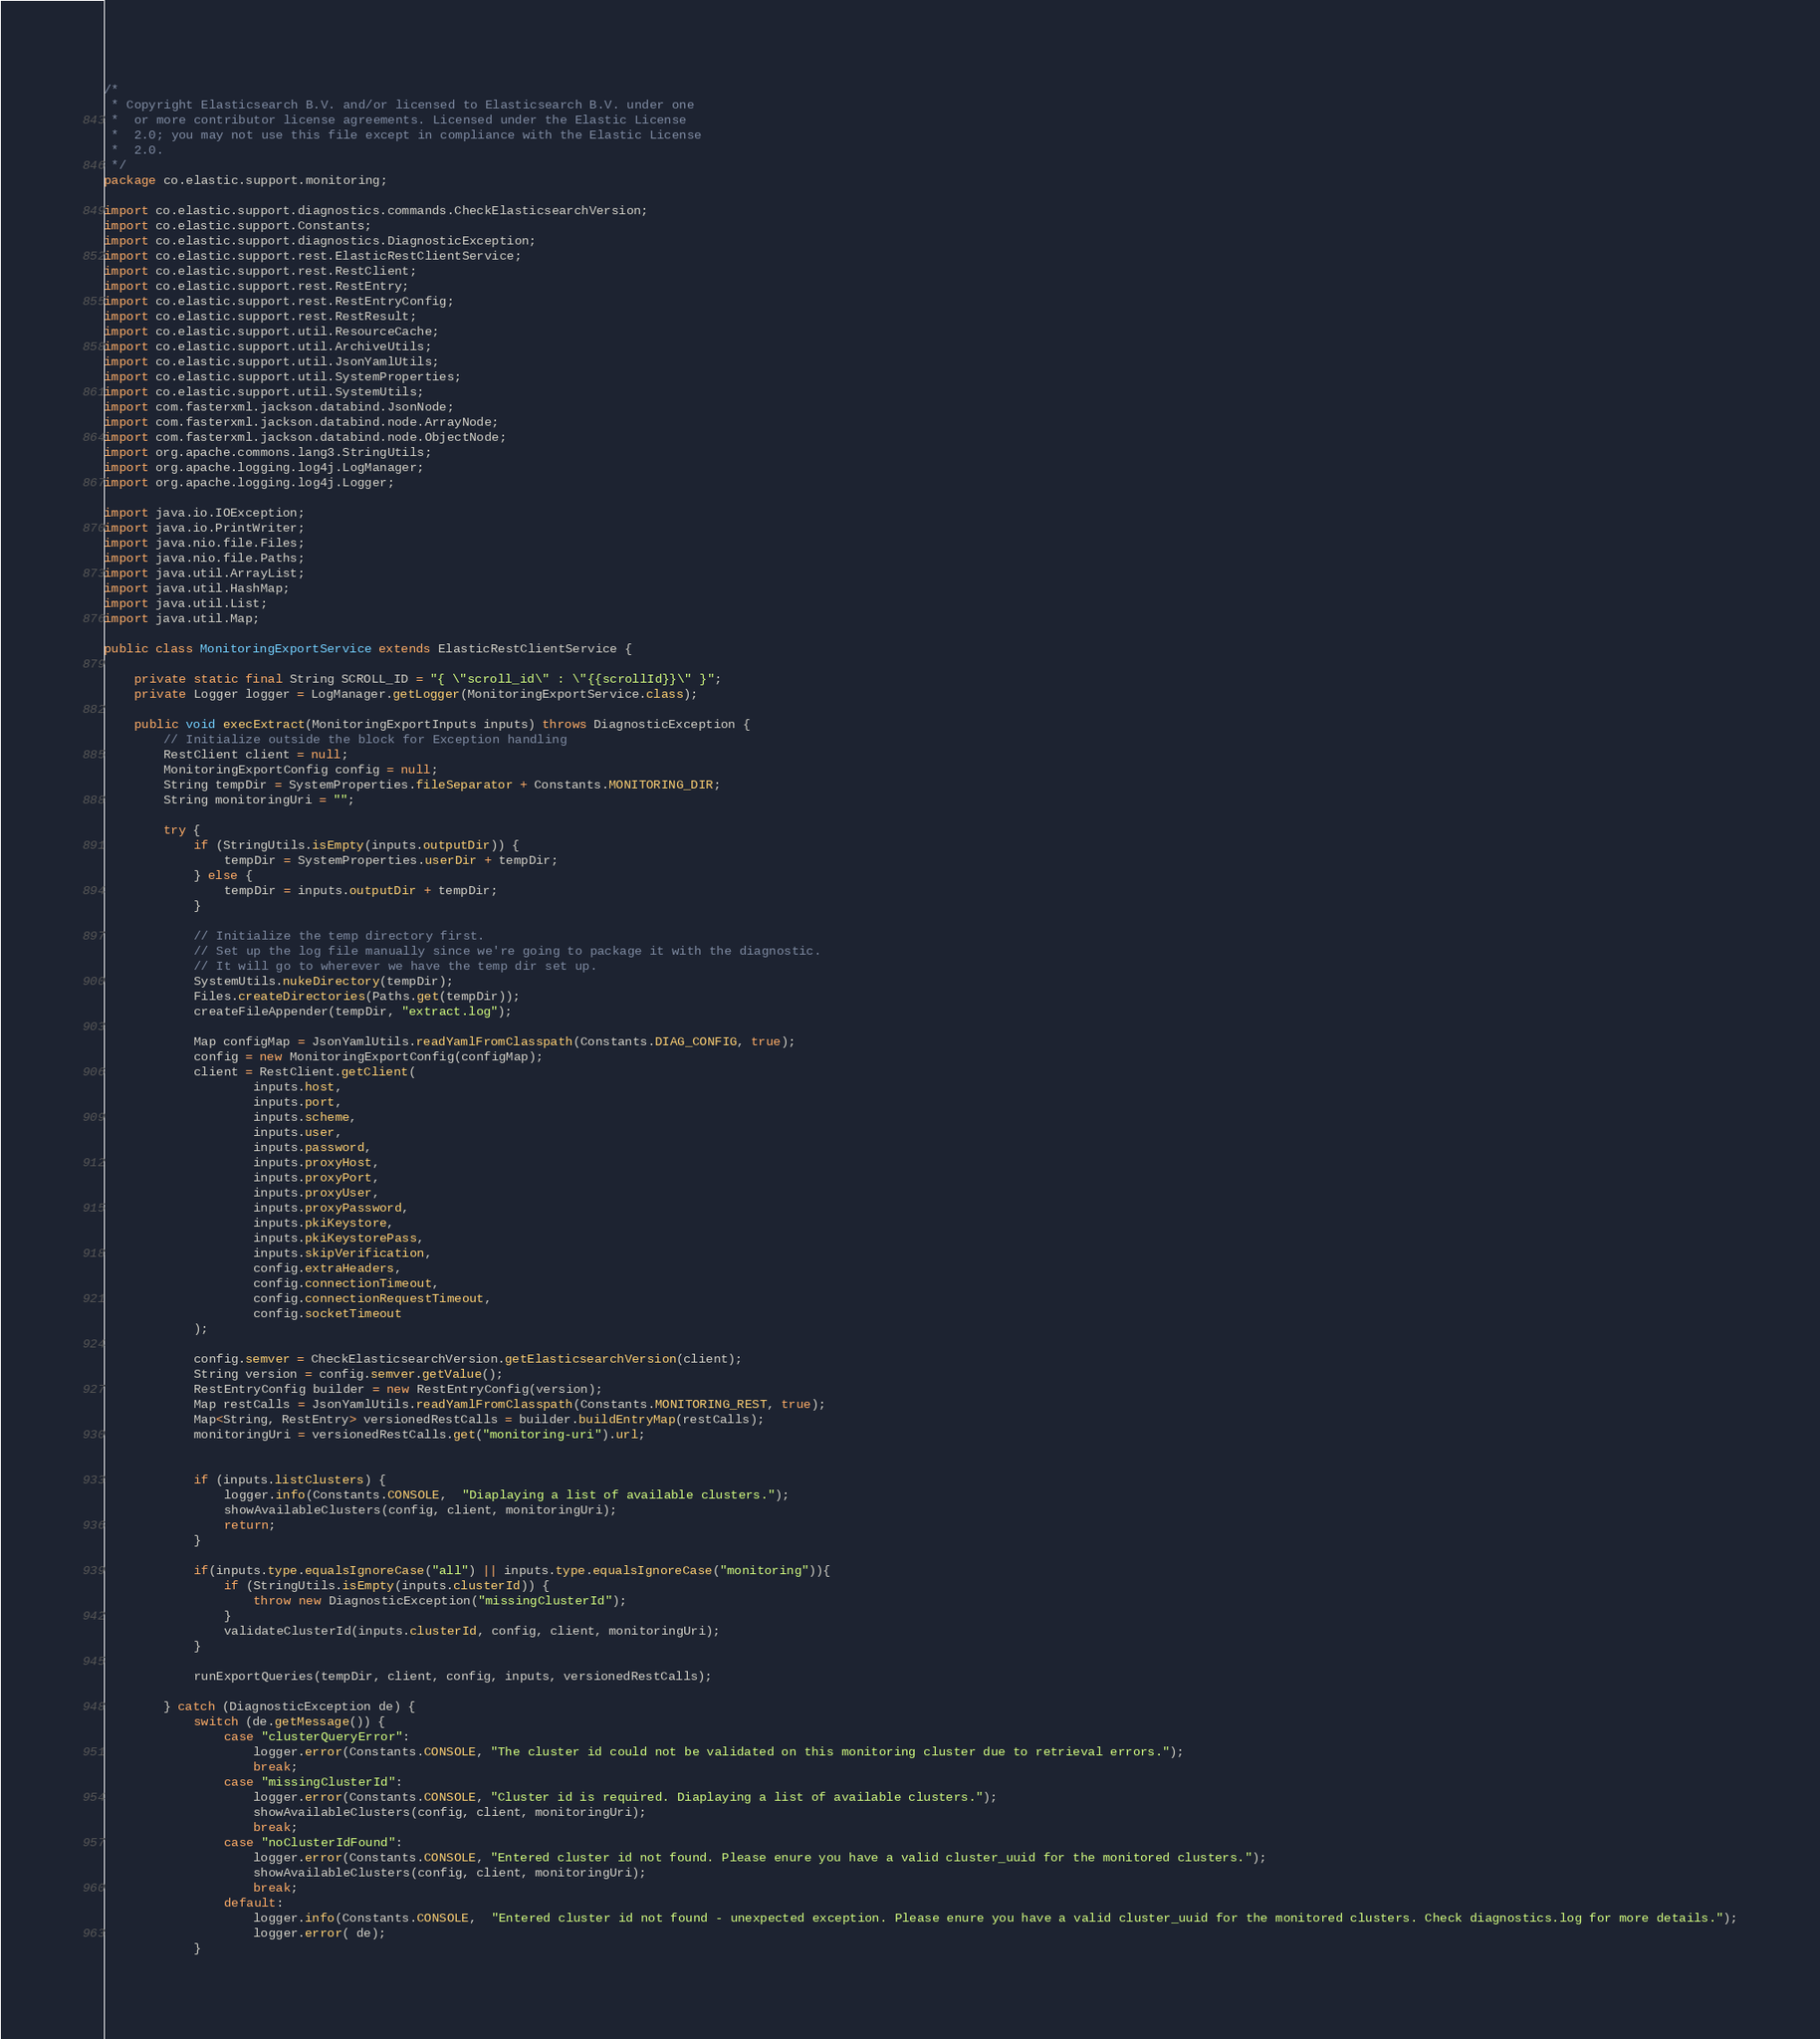Convert code to text. <code><loc_0><loc_0><loc_500><loc_500><_Java_>/*
 * Copyright Elasticsearch B.V. and/or licensed to Elasticsearch B.V. under one
 *  or more contributor license agreements. Licensed under the Elastic License
 *  2.0; you may not use this file except in compliance with the Elastic License
 *  2.0.
 */
package co.elastic.support.monitoring;

import co.elastic.support.diagnostics.commands.CheckElasticsearchVersion;
import co.elastic.support.Constants;
import co.elastic.support.diagnostics.DiagnosticException;
import co.elastic.support.rest.ElasticRestClientService;
import co.elastic.support.rest.RestClient;
import co.elastic.support.rest.RestEntry;
import co.elastic.support.rest.RestEntryConfig;
import co.elastic.support.rest.RestResult;
import co.elastic.support.util.ResourceCache;
import co.elastic.support.util.ArchiveUtils;
import co.elastic.support.util.JsonYamlUtils;
import co.elastic.support.util.SystemProperties;
import co.elastic.support.util.SystemUtils;
import com.fasterxml.jackson.databind.JsonNode;
import com.fasterxml.jackson.databind.node.ArrayNode;
import com.fasterxml.jackson.databind.node.ObjectNode;
import org.apache.commons.lang3.StringUtils;
import org.apache.logging.log4j.LogManager;
import org.apache.logging.log4j.Logger;

import java.io.IOException;
import java.io.PrintWriter;
import java.nio.file.Files;
import java.nio.file.Paths;
import java.util.ArrayList;
import java.util.HashMap;
import java.util.List;
import java.util.Map;

public class MonitoringExportService extends ElasticRestClientService {

    private static final String SCROLL_ID = "{ \"scroll_id\" : \"{{scrollId}}\" }";
    private Logger logger = LogManager.getLogger(MonitoringExportService.class);

    public void execExtract(MonitoringExportInputs inputs) throws DiagnosticException {
        // Initialize outside the block for Exception handling
        RestClient client = null;
        MonitoringExportConfig config = null;
        String tempDir = SystemProperties.fileSeparator + Constants.MONITORING_DIR;
        String monitoringUri = "";

        try {
            if (StringUtils.isEmpty(inputs.outputDir)) {
                tempDir = SystemProperties.userDir + tempDir;
            } else {
                tempDir = inputs.outputDir + tempDir;
            }

            // Initialize the temp directory first.
            // Set up the log file manually since we're going to package it with the diagnostic.
            // It will go to wherever we have the temp dir set up.
            SystemUtils.nukeDirectory(tempDir);
            Files.createDirectories(Paths.get(tempDir));
            createFileAppender(tempDir, "extract.log");

            Map configMap = JsonYamlUtils.readYamlFromClasspath(Constants.DIAG_CONFIG, true);
            config = new MonitoringExportConfig(configMap);
            client = RestClient.getClient(
                    inputs.host,
                    inputs.port,
                    inputs.scheme,
                    inputs.user,
                    inputs.password,
                    inputs.proxyHost,
                    inputs.proxyPort,
                    inputs.proxyUser,
                    inputs.proxyPassword,
                    inputs.pkiKeystore,
                    inputs.pkiKeystorePass,
                    inputs.skipVerification,
                    config.extraHeaders,
                    config.connectionTimeout,
                    config.connectionRequestTimeout,
                    config.socketTimeout
            );

            config.semver = CheckElasticsearchVersion.getElasticsearchVersion(client);
            String version = config.semver.getValue();
            RestEntryConfig builder = new RestEntryConfig(version);
            Map restCalls = JsonYamlUtils.readYamlFromClasspath(Constants.MONITORING_REST, true);
            Map<String, RestEntry> versionedRestCalls = builder.buildEntryMap(restCalls);
            monitoringUri = versionedRestCalls.get("monitoring-uri").url;


            if (inputs.listClusters) {
                logger.info(Constants.CONSOLE,  "Diaplaying a list of available clusters.");
                showAvailableClusters(config, client, monitoringUri);
                return;
            }

            if(inputs.type.equalsIgnoreCase("all") || inputs.type.equalsIgnoreCase("monitoring")){
                if (StringUtils.isEmpty(inputs.clusterId)) {
                    throw new DiagnosticException("missingClusterId");
                }
                validateClusterId(inputs.clusterId, config, client, monitoringUri);
            }

            runExportQueries(tempDir, client, config, inputs, versionedRestCalls);

        } catch (DiagnosticException de) {
            switch (de.getMessage()) {
                case "clusterQueryError":
                    logger.error(Constants.CONSOLE, "The cluster id could not be validated on this monitoring cluster due to retrieval errors.");
                    break;
                case "missingClusterId":
                    logger.error(Constants.CONSOLE, "Cluster id is required. Diaplaying a list of available clusters.");
                    showAvailableClusters(config, client, monitoringUri);
                    break;
                case "noClusterIdFound":
                    logger.error(Constants.CONSOLE, "Entered cluster id not found. Please enure you have a valid cluster_uuid for the monitored clusters.");
                    showAvailableClusters(config, client, monitoringUri);
                    break;
                default:
                    logger.info(Constants.CONSOLE,  "Entered cluster id not found - unexpected exception. Please enure you have a valid cluster_uuid for the monitored clusters. Check diagnostics.log for more details.");
                    logger.error( de);
            }</code> 